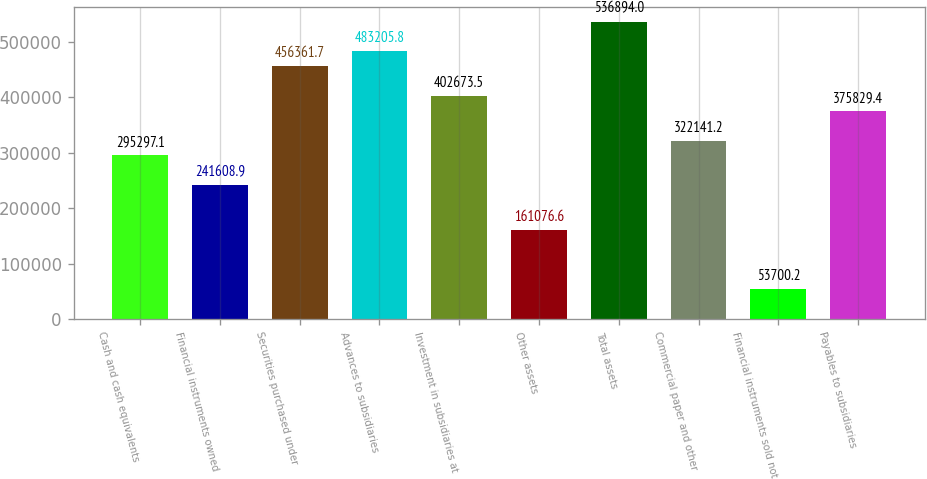<chart> <loc_0><loc_0><loc_500><loc_500><bar_chart><fcel>Cash and cash equivalents<fcel>Financial instruments owned<fcel>Securities purchased under<fcel>Advances to subsidiaries<fcel>Investment in subsidiaries at<fcel>Other assets<fcel>Total assets<fcel>Commercial paper and other<fcel>Financial instruments sold not<fcel>Payables to subsidiaries<nl><fcel>295297<fcel>241609<fcel>456362<fcel>483206<fcel>402674<fcel>161077<fcel>536894<fcel>322141<fcel>53700.2<fcel>375829<nl></chart> 